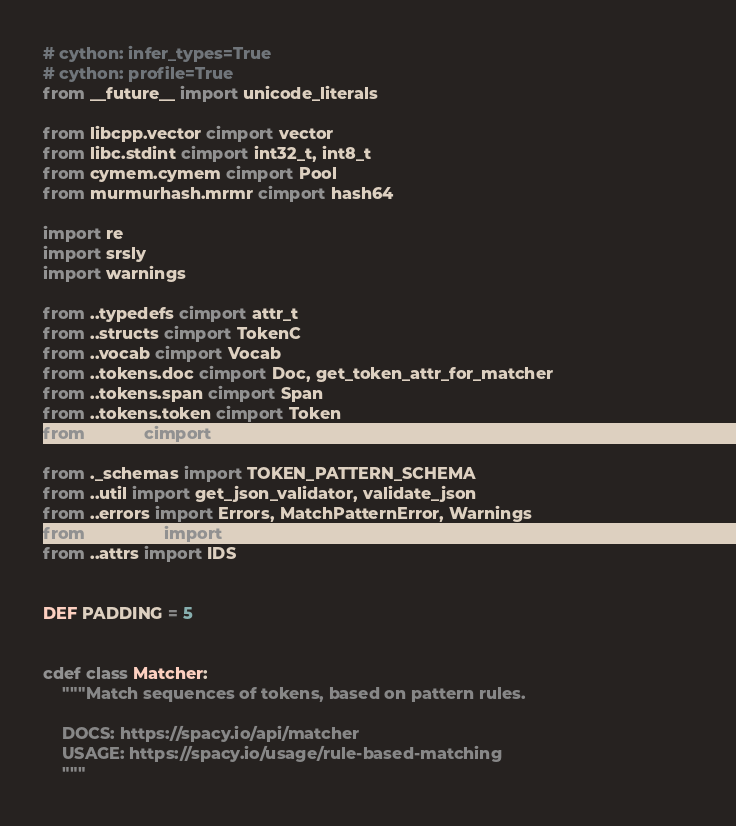Convert code to text. <code><loc_0><loc_0><loc_500><loc_500><_Cython_># cython: infer_types=True
# cython: profile=True
from __future__ import unicode_literals

from libcpp.vector cimport vector
from libc.stdint cimport int32_t, int8_t
from cymem.cymem cimport Pool
from murmurhash.mrmr cimport hash64

import re
import srsly
import warnings

from ..typedefs cimport attr_t
from ..structs cimport TokenC
from ..vocab cimport Vocab
from ..tokens.doc cimport Doc, get_token_attr_for_matcher
from ..tokens.span cimport Span
from ..tokens.token cimport Token
from ..attrs cimport ID, attr_id_t, NULL_ATTR, ORTH, POS, TAG, DEP, LEMMA

from ._schemas import TOKEN_PATTERN_SCHEMA
from ..util import get_json_validator, validate_json
from ..errors import Errors, MatchPatternError, Warnings
from ..strings import get_string_id
from ..attrs import IDS


DEF PADDING = 5


cdef class Matcher:
    """Match sequences of tokens, based on pattern rules.

    DOCS: https://spacy.io/api/matcher
    USAGE: https://spacy.io/usage/rule-based-matching
    """
</code> 